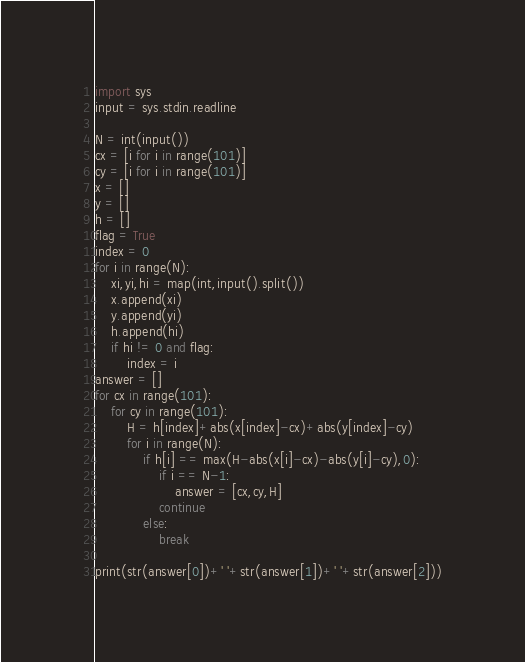Convert code to text. <code><loc_0><loc_0><loc_500><loc_500><_Python_>import sys
input = sys.stdin.readline

N = int(input())
cx = [i for i in range(101)]
cy = [i for i in range(101)]
x = []
y = []
h = []
flag = True
index = 0
for i in range(N):
    xi,yi,hi = map(int,input().split())
    x.append(xi)
    y.append(yi)
    h.append(hi)
    if hi != 0 and flag:
        index = i
answer = []
for cx in range(101):
    for cy in range(101):
        H = h[index]+abs(x[index]-cx)+abs(y[index]-cy)
        for i in range(N):
            if h[i] == max(H-abs(x[i]-cx)-abs(y[i]-cy),0):
                if i == N-1:
                    answer = [cx,cy,H]
                continue
            else:
                break

print(str(answer[0])+' '+str(answer[1])+' '+str(answer[2]))

</code> 